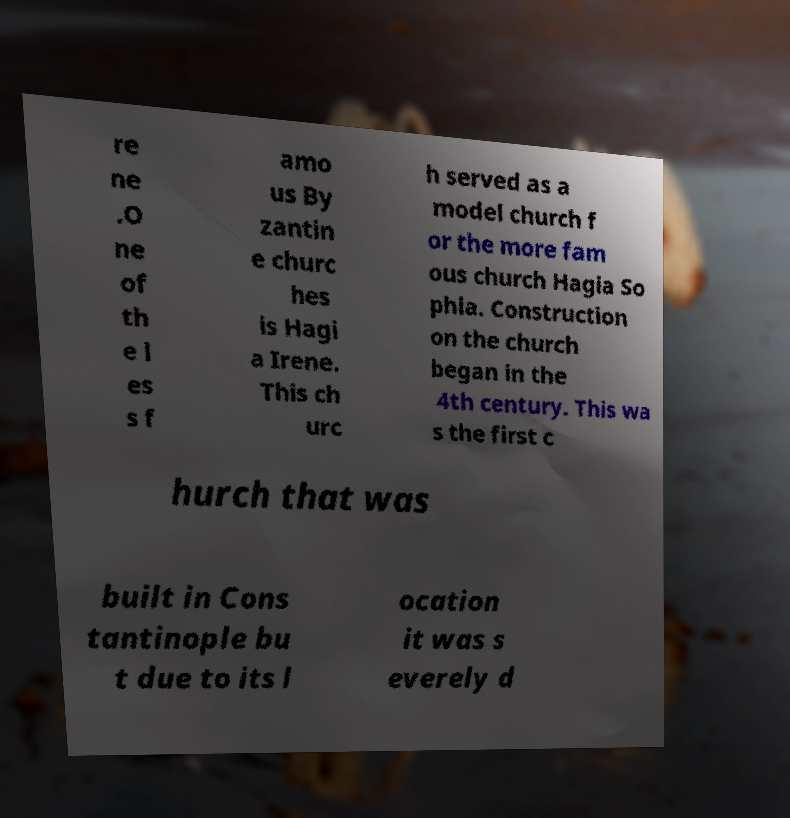Please read and relay the text visible in this image. What does it say? re ne .O ne of th e l es s f amo us By zantin e churc hes is Hagi a Irene. This ch urc h served as a model church f or the more fam ous church Hagia So phia. Construction on the church began in the 4th century. This wa s the first c hurch that was built in Cons tantinople bu t due to its l ocation it was s everely d 